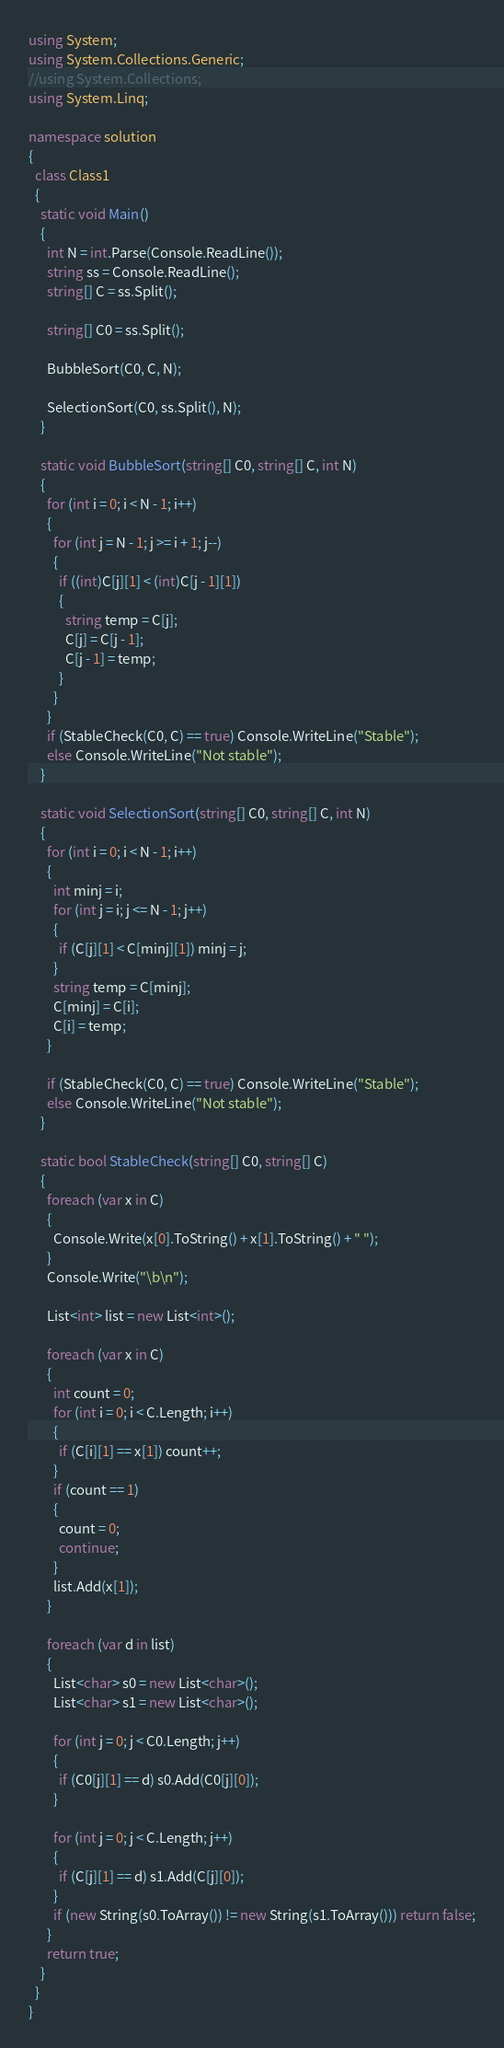Convert code to text. <code><loc_0><loc_0><loc_500><loc_500><_C#_>using System;
using System.Collections.Generic;
//using System.Collections;
using System.Linq;

namespace solution
{
  class Class1
  {
    static void Main()
    {
      int N = int.Parse(Console.ReadLine());
      string ss = Console.ReadLine();
      string[] C = ss.Split();

      string[] C0 = ss.Split();

      BubbleSort(C0, C, N);

      SelectionSort(C0, ss.Split(), N);
    }

    static void BubbleSort(string[] C0, string[] C, int N)
    {
      for (int i = 0; i < N - 1; i++)
      {
        for (int j = N - 1; j >= i + 1; j--)
        {
          if ((int)C[j][1] < (int)C[j - 1][1])
          {
            string temp = C[j];
            C[j] = C[j - 1];
            C[j - 1] = temp;
          }
        }
      }
      if (StableCheck(C0, C) == true) Console.WriteLine("Stable");
      else Console.WriteLine("Not stable");
    }

    static void SelectionSort(string[] C0, string[] C, int N)
    {
      for (int i = 0; i < N - 1; i++)
      {
        int minj = i;
        for (int j = i; j <= N - 1; j++)
        {
          if (C[j][1] < C[minj][1]) minj = j;
        }
        string temp = C[minj];
        C[minj] = C[i];
        C[i] = temp;
      }

      if (StableCheck(C0, C) == true) Console.WriteLine("Stable");
      else Console.WriteLine("Not stable");
    }

    static bool StableCheck(string[] C0, string[] C)
    {
      foreach (var x in C)
      {
        Console.Write(x[0].ToString() + x[1].ToString() + " ");
      }
      Console.Write("\b\n");

      List<int> list = new List<int>();

      foreach (var x in C)
      {
        int count = 0;
        for (int i = 0; i < C.Length; i++)
        {
          if (C[i][1] == x[1]) count++;
        }
        if (count == 1)
        {
          count = 0;
          continue;
        }
        list.Add(x[1]);
      }

      foreach (var d in list)
      {
        List<char> s0 = new List<char>();
        List<char> s1 = new List<char>();

        for (int j = 0; j < C0.Length; j++)
        {
          if (C0[j][1] == d) s0.Add(C0[j][0]);
        }

        for (int j = 0; j < C.Length; j++)
        {
          if (C[j][1] == d) s1.Add(C[j][0]);
        }
        if (new String(s0.ToArray()) != new String(s1.ToArray())) return false;
      }
      return true;
    }
  }
}







</code> 